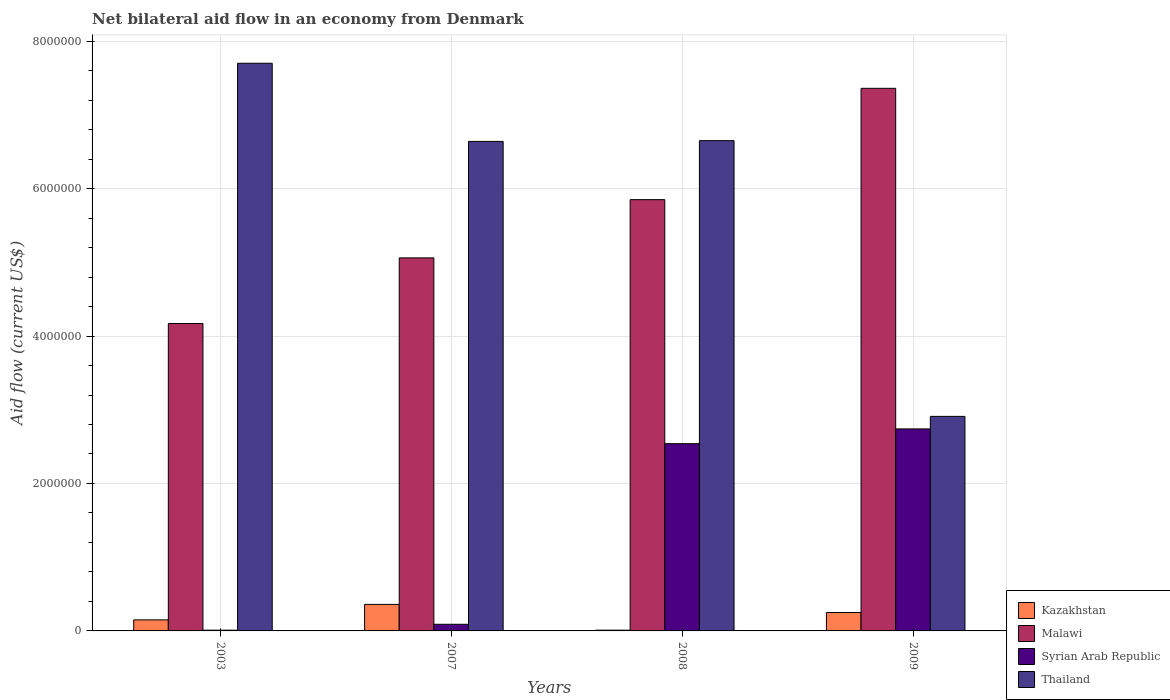How many groups of bars are there?
Offer a terse response. 4. Are the number of bars per tick equal to the number of legend labels?
Your response must be concise. Yes. Are the number of bars on each tick of the X-axis equal?
Your answer should be very brief. Yes. How many bars are there on the 1st tick from the right?
Ensure brevity in your answer.  4. What is the label of the 2nd group of bars from the left?
Give a very brief answer. 2007. In how many cases, is the number of bars for a given year not equal to the number of legend labels?
Your answer should be compact. 0. Across all years, what is the maximum net bilateral aid flow in Thailand?
Ensure brevity in your answer.  7.70e+06. In which year was the net bilateral aid flow in Malawi maximum?
Your answer should be compact. 2009. What is the total net bilateral aid flow in Malawi in the graph?
Your answer should be compact. 2.24e+07. What is the difference between the net bilateral aid flow in Syrian Arab Republic in 2008 and the net bilateral aid flow in Kazakhstan in 2007?
Your answer should be very brief. 2.18e+06. What is the average net bilateral aid flow in Thailand per year?
Give a very brief answer. 5.98e+06. In the year 2008, what is the difference between the net bilateral aid flow in Thailand and net bilateral aid flow in Syrian Arab Republic?
Give a very brief answer. 4.11e+06. In how many years, is the net bilateral aid flow in Syrian Arab Republic greater than 7200000 US$?
Your answer should be very brief. 0. What is the ratio of the net bilateral aid flow in Thailand in 2007 to that in 2009?
Give a very brief answer. 2.28. What is the difference between the highest and the second highest net bilateral aid flow in Malawi?
Keep it short and to the point. 1.51e+06. What is the difference between the highest and the lowest net bilateral aid flow in Thailand?
Provide a succinct answer. 4.79e+06. In how many years, is the net bilateral aid flow in Syrian Arab Republic greater than the average net bilateral aid flow in Syrian Arab Republic taken over all years?
Provide a short and direct response. 2. Is the sum of the net bilateral aid flow in Malawi in 2007 and 2008 greater than the maximum net bilateral aid flow in Thailand across all years?
Make the answer very short. Yes. What does the 2nd bar from the left in 2007 represents?
Make the answer very short. Malawi. What does the 3rd bar from the right in 2008 represents?
Keep it short and to the point. Malawi. Is it the case that in every year, the sum of the net bilateral aid flow in Kazakhstan and net bilateral aid flow in Syrian Arab Republic is greater than the net bilateral aid flow in Thailand?
Offer a terse response. No. How many bars are there?
Offer a terse response. 16. What is the difference between two consecutive major ticks on the Y-axis?
Provide a succinct answer. 2.00e+06. Does the graph contain any zero values?
Give a very brief answer. No. Does the graph contain grids?
Make the answer very short. Yes. What is the title of the graph?
Provide a short and direct response. Net bilateral aid flow in an economy from Denmark. Does "Slovak Republic" appear as one of the legend labels in the graph?
Ensure brevity in your answer.  No. What is the Aid flow (current US$) of Kazakhstan in 2003?
Your answer should be very brief. 1.50e+05. What is the Aid flow (current US$) in Malawi in 2003?
Provide a short and direct response. 4.17e+06. What is the Aid flow (current US$) in Syrian Arab Republic in 2003?
Your response must be concise. 10000. What is the Aid flow (current US$) in Thailand in 2003?
Your answer should be compact. 7.70e+06. What is the Aid flow (current US$) of Kazakhstan in 2007?
Keep it short and to the point. 3.60e+05. What is the Aid flow (current US$) in Malawi in 2007?
Keep it short and to the point. 5.06e+06. What is the Aid flow (current US$) of Thailand in 2007?
Provide a succinct answer. 6.64e+06. What is the Aid flow (current US$) in Kazakhstan in 2008?
Make the answer very short. 10000. What is the Aid flow (current US$) of Malawi in 2008?
Keep it short and to the point. 5.85e+06. What is the Aid flow (current US$) of Syrian Arab Republic in 2008?
Give a very brief answer. 2.54e+06. What is the Aid flow (current US$) of Thailand in 2008?
Keep it short and to the point. 6.65e+06. What is the Aid flow (current US$) in Malawi in 2009?
Keep it short and to the point. 7.36e+06. What is the Aid flow (current US$) of Syrian Arab Republic in 2009?
Keep it short and to the point. 2.74e+06. What is the Aid flow (current US$) of Thailand in 2009?
Your answer should be very brief. 2.91e+06. Across all years, what is the maximum Aid flow (current US$) in Malawi?
Give a very brief answer. 7.36e+06. Across all years, what is the maximum Aid flow (current US$) in Syrian Arab Republic?
Offer a terse response. 2.74e+06. Across all years, what is the maximum Aid flow (current US$) in Thailand?
Your answer should be very brief. 7.70e+06. Across all years, what is the minimum Aid flow (current US$) of Malawi?
Offer a terse response. 4.17e+06. Across all years, what is the minimum Aid flow (current US$) in Thailand?
Offer a terse response. 2.91e+06. What is the total Aid flow (current US$) in Kazakhstan in the graph?
Provide a short and direct response. 7.70e+05. What is the total Aid flow (current US$) of Malawi in the graph?
Make the answer very short. 2.24e+07. What is the total Aid flow (current US$) of Syrian Arab Republic in the graph?
Provide a short and direct response. 5.38e+06. What is the total Aid flow (current US$) of Thailand in the graph?
Provide a short and direct response. 2.39e+07. What is the difference between the Aid flow (current US$) in Malawi in 2003 and that in 2007?
Provide a short and direct response. -8.90e+05. What is the difference between the Aid flow (current US$) of Thailand in 2003 and that in 2007?
Your answer should be compact. 1.06e+06. What is the difference between the Aid flow (current US$) of Kazakhstan in 2003 and that in 2008?
Offer a very short reply. 1.40e+05. What is the difference between the Aid flow (current US$) of Malawi in 2003 and that in 2008?
Offer a terse response. -1.68e+06. What is the difference between the Aid flow (current US$) of Syrian Arab Republic in 2003 and that in 2008?
Your response must be concise. -2.53e+06. What is the difference between the Aid flow (current US$) in Thailand in 2003 and that in 2008?
Make the answer very short. 1.05e+06. What is the difference between the Aid flow (current US$) in Kazakhstan in 2003 and that in 2009?
Make the answer very short. -1.00e+05. What is the difference between the Aid flow (current US$) of Malawi in 2003 and that in 2009?
Provide a short and direct response. -3.19e+06. What is the difference between the Aid flow (current US$) in Syrian Arab Republic in 2003 and that in 2009?
Ensure brevity in your answer.  -2.73e+06. What is the difference between the Aid flow (current US$) of Thailand in 2003 and that in 2009?
Offer a terse response. 4.79e+06. What is the difference between the Aid flow (current US$) in Malawi in 2007 and that in 2008?
Ensure brevity in your answer.  -7.90e+05. What is the difference between the Aid flow (current US$) of Syrian Arab Republic in 2007 and that in 2008?
Your answer should be compact. -2.45e+06. What is the difference between the Aid flow (current US$) of Kazakhstan in 2007 and that in 2009?
Make the answer very short. 1.10e+05. What is the difference between the Aid flow (current US$) of Malawi in 2007 and that in 2009?
Provide a short and direct response. -2.30e+06. What is the difference between the Aid flow (current US$) in Syrian Arab Republic in 2007 and that in 2009?
Offer a terse response. -2.65e+06. What is the difference between the Aid flow (current US$) of Thailand in 2007 and that in 2009?
Offer a terse response. 3.73e+06. What is the difference between the Aid flow (current US$) of Malawi in 2008 and that in 2009?
Ensure brevity in your answer.  -1.51e+06. What is the difference between the Aid flow (current US$) in Thailand in 2008 and that in 2009?
Offer a very short reply. 3.74e+06. What is the difference between the Aid flow (current US$) of Kazakhstan in 2003 and the Aid flow (current US$) of Malawi in 2007?
Make the answer very short. -4.91e+06. What is the difference between the Aid flow (current US$) of Kazakhstan in 2003 and the Aid flow (current US$) of Syrian Arab Republic in 2007?
Offer a very short reply. 6.00e+04. What is the difference between the Aid flow (current US$) in Kazakhstan in 2003 and the Aid flow (current US$) in Thailand in 2007?
Offer a terse response. -6.49e+06. What is the difference between the Aid flow (current US$) of Malawi in 2003 and the Aid flow (current US$) of Syrian Arab Republic in 2007?
Keep it short and to the point. 4.08e+06. What is the difference between the Aid flow (current US$) of Malawi in 2003 and the Aid flow (current US$) of Thailand in 2007?
Ensure brevity in your answer.  -2.47e+06. What is the difference between the Aid flow (current US$) of Syrian Arab Republic in 2003 and the Aid flow (current US$) of Thailand in 2007?
Your response must be concise. -6.63e+06. What is the difference between the Aid flow (current US$) of Kazakhstan in 2003 and the Aid flow (current US$) of Malawi in 2008?
Provide a short and direct response. -5.70e+06. What is the difference between the Aid flow (current US$) of Kazakhstan in 2003 and the Aid flow (current US$) of Syrian Arab Republic in 2008?
Provide a short and direct response. -2.39e+06. What is the difference between the Aid flow (current US$) in Kazakhstan in 2003 and the Aid flow (current US$) in Thailand in 2008?
Your answer should be compact. -6.50e+06. What is the difference between the Aid flow (current US$) in Malawi in 2003 and the Aid flow (current US$) in Syrian Arab Republic in 2008?
Your answer should be very brief. 1.63e+06. What is the difference between the Aid flow (current US$) in Malawi in 2003 and the Aid flow (current US$) in Thailand in 2008?
Give a very brief answer. -2.48e+06. What is the difference between the Aid flow (current US$) of Syrian Arab Republic in 2003 and the Aid flow (current US$) of Thailand in 2008?
Ensure brevity in your answer.  -6.64e+06. What is the difference between the Aid flow (current US$) in Kazakhstan in 2003 and the Aid flow (current US$) in Malawi in 2009?
Provide a succinct answer. -7.21e+06. What is the difference between the Aid flow (current US$) in Kazakhstan in 2003 and the Aid flow (current US$) in Syrian Arab Republic in 2009?
Offer a very short reply. -2.59e+06. What is the difference between the Aid flow (current US$) of Kazakhstan in 2003 and the Aid flow (current US$) of Thailand in 2009?
Provide a short and direct response. -2.76e+06. What is the difference between the Aid flow (current US$) of Malawi in 2003 and the Aid flow (current US$) of Syrian Arab Republic in 2009?
Give a very brief answer. 1.43e+06. What is the difference between the Aid flow (current US$) of Malawi in 2003 and the Aid flow (current US$) of Thailand in 2009?
Make the answer very short. 1.26e+06. What is the difference between the Aid flow (current US$) of Syrian Arab Republic in 2003 and the Aid flow (current US$) of Thailand in 2009?
Offer a very short reply. -2.90e+06. What is the difference between the Aid flow (current US$) in Kazakhstan in 2007 and the Aid flow (current US$) in Malawi in 2008?
Provide a short and direct response. -5.49e+06. What is the difference between the Aid flow (current US$) of Kazakhstan in 2007 and the Aid flow (current US$) of Syrian Arab Republic in 2008?
Provide a short and direct response. -2.18e+06. What is the difference between the Aid flow (current US$) in Kazakhstan in 2007 and the Aid flow (current US$) in Thailand in 2008?
Provide a succinct answer. -6.29e+06. What is the difference between the Aid flow (current US$) in Malawi in 2007 and the Aid flow (current US$) in Syrian Arab Republic in 2008?
Give a very brief answer. 2.52e+06. What is the difference between the Aid flow (current US$) of Malawi in 2007 and the Aid flow (current US$) of Thailand in 2008?
Your answer should be very brief. -1.59e+06. What is the difference between the Aid flow (current US$) in Syrian Arab Republic in 2007 and the Aid flow (current US$) in Thailand in 2008?
Your answer should be compact. -6.56e+06. What is the difference between the Aid flow (current US$) in Kazakhstan in 2007 and the Aid flow (current US$) in Malawi in 2009?
Your answer should be compact. -7.00e+06. What is the difference between the Aid flow (current US$) of Kazakhstan in 2007 and the Aid flow (current US$) of Syrian Arab Republic in 2009?
Ensure brevity in your answer.  -2.38e+06. What is the difference between the Aid flow (current US$) of Kazakhstan in 2007 and the Aid flow (current US$) of Thailand in 2009?
Provide a short and direct response. -2.55e+06. What is the difference between the Aid flow (current US$) of Malawi in 2007 and the Aid flow (current US$) of Syrian Arab Republic in 2009?
Your answer should be compact. 2.32e+06. What is the difference between the Aid flow (current US$) in Malawi in 2007 and the Aid flow (current US$) in Thailand in 2009?
Provide a short and direct response. 2.15e+06. What is the difference between the Aid flow (current US$) of Syrian Arab Republic in 2007 and the Aid flow (current US$) of Thailand in 2009?
Provide a succinct answer. -2.82e+06. What is the difference between the Aid flow (current US$) in Kazakhstan in 2008 and the Aid flow (current US$) in Malawi in 2009?
Keep it short and to the point. -7.35e+06. What is the difference between the Aid flow (current US$) of Kazakhstan in 2008 and the Aid flow (current US$) of Syrian Arab Republic in 2009?
Your answer should be very brief. -2.73e+06. What is the difference between the Aid flow (current US$) of Kazakhstan in 2008 and the Aid flow (current US$) of Thailand in 2009?
Ensure brevity in your answer.  -2.90e+06. What is the difference between the Aid flow (current US$) in Malawi in 2008 and the Aid flow (current US$) in Syrian Arab Republic in 2009?
Give a very brief answer. 3.11e+06. What is the difference between the Aid flow (current US$) in Malawi in 2008 and the Aid flow (current US$) in Thailand in 2009?
Ensure brevity in your answer.  2.94e+06. What is the difference between the Aid flow (current US$) in Syrian Arab Republic in 2008 and the Aid flow (current US$) in Thailand in 2009?
Your answer should be very brief. -3.70e+05. What is the average Aid flow (current US$) in Kazakhstan per year?
Offer a very short reply. 1.92e+05. What is the average Aid flow (current US$) of Malawi per year?
Provide a short and direct response. 5.61e+06. What is the average Aid flow (current US$) in Syrian Arab Republic per year?
Keep it short and to the point. 1.34e+06. What is the average Aid flow (current US$) in Thailand per year?
Provide a succinct answer. 5.98e+06. In the year 2003, what is the difference between the Aid flow (current US$) of Kazakhstan and Aid flow (current US$) of Malawi?
Provide a short and direct response. -4.02e+06. In the year 2003, what is the difference between the Aid flow (current US$) of Kazakhstan and Aid flow (current US$) of Thailand?
Give a very brief answer. -7.55e+06. In the year 2003, what is the difference between the Aid flow (current US$) of Malawi and Aid flow (current US$) of Syrian Arab Republic?
Offer a very short reply. 4.16e+06. In the year 2003, what is the difference between the Aid flow (current US$) in Malawi and Aid flow (current US$) in Thailand?
Offer a very short reply. -3.53e+06. In the year 2003, what is the difference between the Aid flow (current US$) in Syrian Arab Republic and Aid flow (current US$) in Thailand?
Provide a succinct answer. -7.69e+06. In the year 2007, what is the difference between the Aid flow (current US$) of Kazakhstan and Aid flow (current US$) of Malawi?
Keep it short and to the point. -4.70e+06. In the year 2007, what is the difference between the Aid flow (current US$) of Kazakhstan and Aid flow (current US$) of Thailand?
Provide a succinct answer. -6.28e+06. In the year 2007, what is the difference between the Aid flow (current US$) in Malawi and Aid flow (current US$) in Syrian Arab Republic?
Keep it short and to the point. 4.97e+06. In the year 2007, what is the difference between the Aid flow (current US$) in Malawi and Aid flow (current US$) in Thailand?
Provide a succinct answer. -1.58e+06. In the year 2007, what is the difference between the Aid flow (current US$) of Syrian Arab Republic and Aid flow (current US$) of Thailand?
Provide a succinct answer. -6.55e+06. In the year 2008, what is the difference between the Aid flow (current US$) in Kazakhstan and Aid flow (current US$) in Malawi?
Ensure brevity in your answer.  -5.84e+06. In the year 2008, what is the difference between the Aid flow (current US$) of Kazakhstan and Aid flow (current US$) of Syrian Arab Republic?
Ensure brevity in your answer.  -2.53e+06. In the year 2008, what is the difference between the Aid flow (current US$) in Kazakhstan and Aid flow (current US$) in Thailand?
Provide a succinct answer. -6.64e+06. In the year 2008, what is the difference between the Aid flow (current US$) in Malawi and Aid flow (current US$) in Syrian Arab Republic?
Offer a very short reply. 3.31e+06. In the year 2008, what is the difference between the Aid flow (current US$) in Malawi and Aid flow (current US$) in Thailand?
Ensure brevity in your answer.  -8.00e+05. In the year 2008, what is the difference between the Aid flow (current US$) in Syrian Arab Republic and Aid flow (current US$) in Thailand?
Offer a terse response. -4.11e+06. In the year 2009, what is the difference between the Aid flow (current US$) in Kazakhstan and Aid flow (current US$) in Malawi?
Give a very brief answer. -7.11e+06. In the year 2009, what is the difference between the Aid flow (current US$) in Kazakhstan and Aid flow (current US$) in Syrian Arab Republic?
Offer a terse response. -2.49e+06. In the year 2009, what is the difference between the Aid flow (current US$) in Kazakhstan and Aid flow (current US$) in Thailand?
Offer a very short reply. -2.66e+06. In the year 2009, what is the difference between the Aid flow (current US$) of Malawi and Aid flow (current US$) of Syrian Arab Republic?
Provide a short and direct response. 4.62e+06. In the year 2009, what is the difference between the Aid flow (current US$) of Malawi and Aid flow (current US$) of Thailand?
Make the answer very short. 4.45e+06. In the year 2009, what is the difference between the Aid flow (current US$) of Syrian Arab Republic and Aid flow (current US$) of Thailand?
Keep it short and to the point. -1.70e+05. What is the ratio of the Aid flow (current US$) of Kazakhstan in 2003 to that in 2007?
Give a very brief answer. 0.42. What is the ratio of the Aid flow (current US$) of Malawi in 2003 to that in 2007?
Provide a succinct answer. 0.82. What is the ratio of the Aid flow (current US$) in Thailand in 2003 to that in 2007?
Offer a very short reply. 1.16. What is the ratio of the Aid flow (current US$) in Kazakhstan in 2003 to that in 2008?
Provide a succinct answer. 15. What is the ratio of the Aid flow (current US$) in Malawi in 2003 to that in 2008?
Give a very brief answer. 0.71. What is the ratio of the Aid flow (current US$) in Syrian Arab Republic in 2003 to that in 2008?
Ensure brevity in your answer.  0. What is the ratio of the Aid flow (current US$) of Thailand in 2003 to that in 2008?
Ensure brevity in your answer.  1.16. What is the ratio of the Aid flow (current US$) of Malawi in 2003 to that in 2009?
Keep it short and to the point. 0.57. What is the ratio of the Aid flow (current US$) in Syrian Arab Republic in 2003 to that in 2009?
Offer a very short reply. 0. What is the ratio of the Aid flow (current US$) in Thailand in 2003 to that in 2009?
Your answer should be compact. 2.65. What is the ratio of the Aid flow (current US$) of Malawi in 2007 to that in 2008?
Give a very brief answer. 0.86. What is the ratio of the Aid flow (current US$) in Syrian Arab Republic in 2007 to that in 2008?
Your answer should be compact. 0.04. What is the ratio of the Aid flow (current US$) of Thailand in 2007 to that in 2008?
Give a very brief answer. 1. What is the ratio of the Aid flow (current US$) of Kazakhstan in 2007 to that in 2009?
Provide a short and direct response. 1.44. What is the ratio of the Aid flow (current US$) of Malawi in 2007 to that in 2009?
Keep it short and to the point. 0.69. What is the ratio of the Aid flow (current US$) in Syrian Arab Republic in 2007 to that in 2009?
Give a very brief answer. 0.03. What is the ratio of the Aid flow (current US$) in Thailand in 2007 to that in 2009?
Provide a short and direct response. 2.28. What is the ratio of the Aid flow (current US$) of Malawi in 2008 to that in 2009?
Your answer should be very brief. 0.79. What is the ratio of the Aid flow (current US$) of Syrian Arab Republic in 2008 to that in 2009?
Your response must be concise. 0.93. What is the ratio of the Aid flow (current US$) of Thailand in 2008 to that in 2009?
Ensure brevity in your answer.  2.29. What is the difference between the highest and the second highest Aid flow (current US$) of Kazakhstan?
Your response must be concise. 1.10e+05. What is the difference between the highest and the second highest Aid flow (current US$) in Malawi?
Ensure brevity in your answer.  1.51e+06. What is the difference between the highest and the second highest Aid flow (current US$) in Syrian Arab Republic?
Your answer should be compact. 2.00e+05. What is the difference between the highest and the second highest Aid flow (current US$) of Thailand?
Provide a short and direct response. 1.05e+06. What is the difference between the highest and the lowest Aid flow (current US$) of Malawi?
Provide a succinct answer. 3.19e+06. What is the difference between the highest and the lowest Aid flow (current US$) of Syrian Arab Republic?
Keep it short and to the point. 2.73e+06. What is the difference between the highest and the lowest Aid flow (current US$) in Thailand?
Keep it short and to the point. 4.79e+06. 